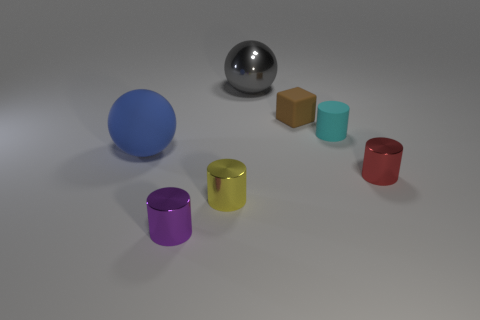Is there any other thing that has the same shape as the small brown thing?
Give a very brief answer. No. Do the rubber block and the small rubber cylinder have the same color?
Offer a very short reply. No. How many other things are there of the same shape as the red shiny object?
Your answer should be very brief. 3. Are there the same number of red cylinders that are on the left side of the tiny purple thing and red objects?
Your answer should be compact. No. What is the shape of the tiny red object that is the same material as the large gray sphere?
Your answer should be compact. Cylinder. Is there a thing of the same color as the matte ball?
Your response must be concise. No. How many shiny objects are tiny gray cubes or purple cylinders?
Your answer should be compact. 1. What number of red objects are to the left of the metal cylinder that is to the right of the tiny cyan cylinder?
Make the answer very short. 0. What number of tiny purple things have the same material as the yellow cylinder?
Offer a very short reply. 1. What number of big things are either brown blocks or purple rubber cylinders?
Provide a short and direct response. 0. 